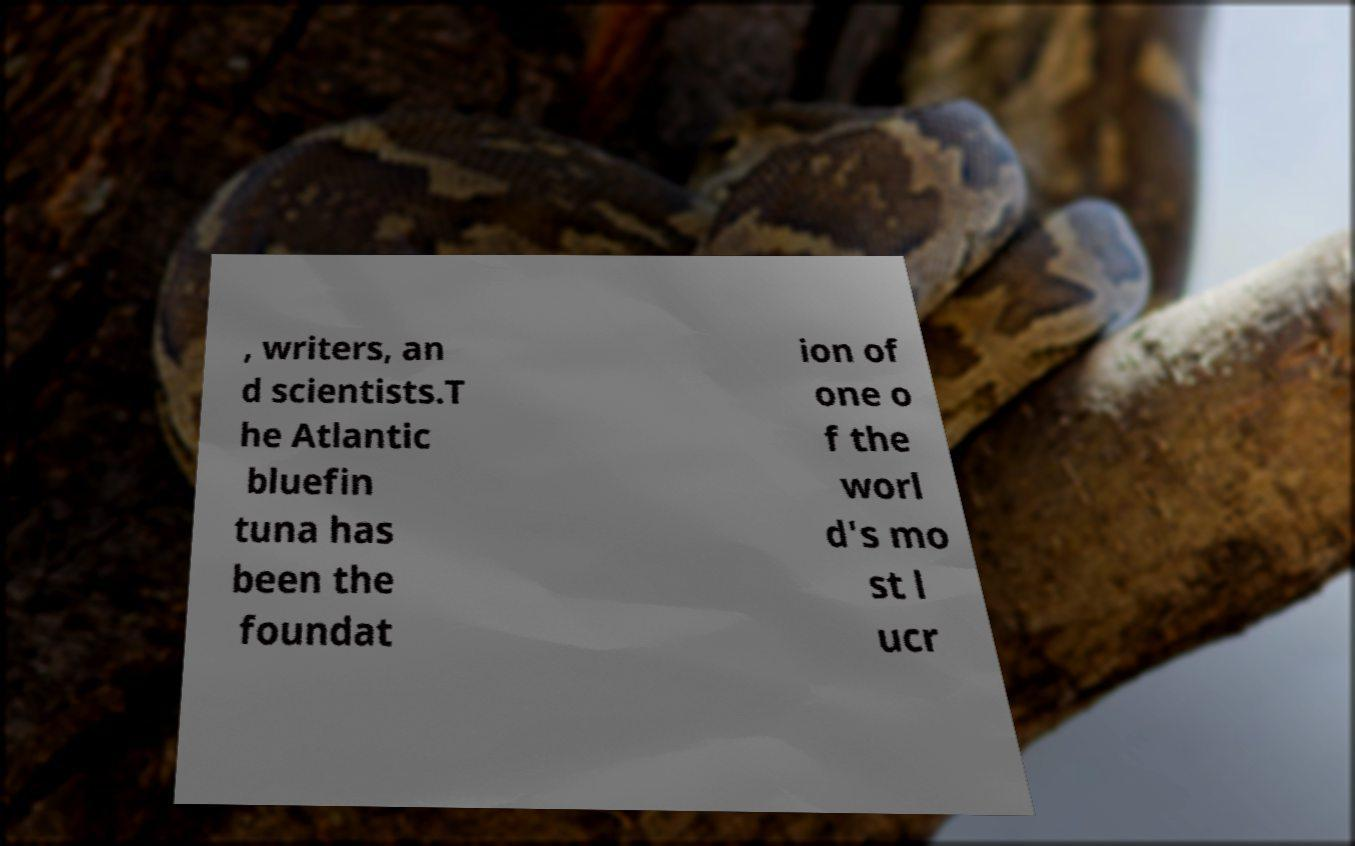I need the written content from this picture converted into text. Can you do that? , writers, an d scientists.T he Atlantic bluefin tuna has been the foundat ion of one o f the worl d's mo st l ucr 